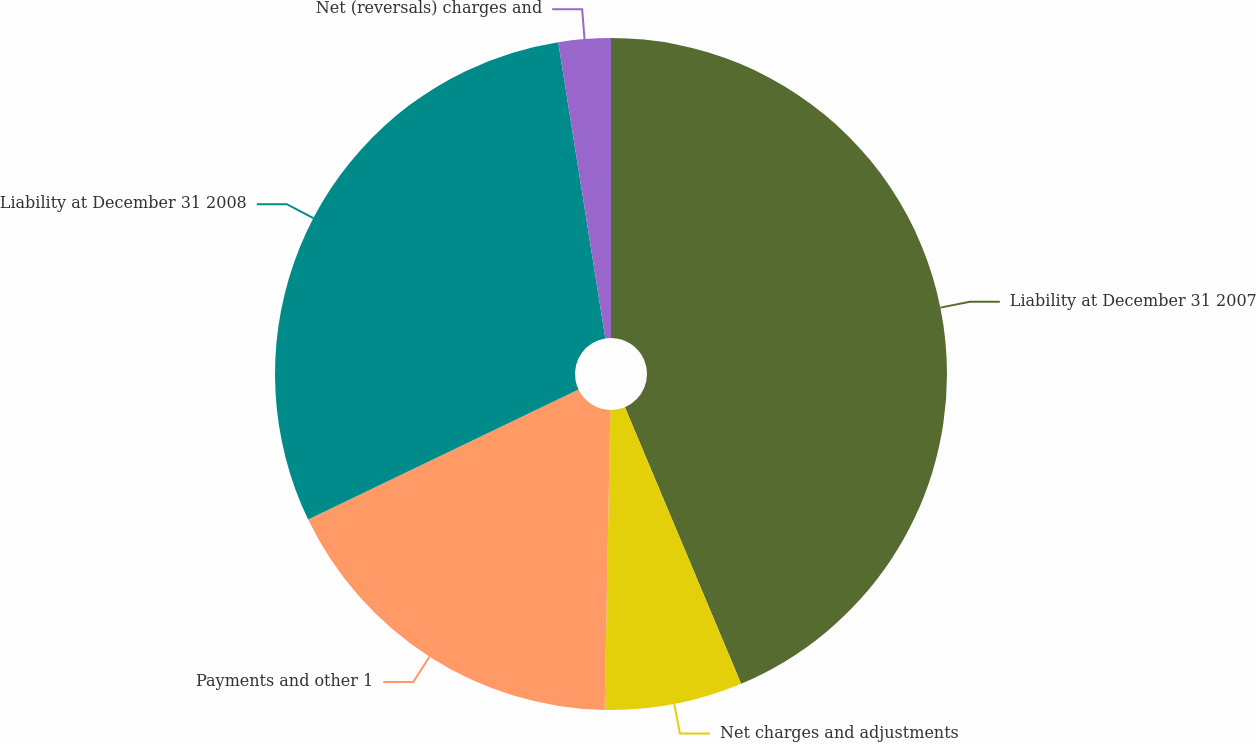Convert chart. <chart><loc_0><loc_0><loc_500><loc_500><pie_chart><fcel>Liability at December 31 2007<fcel>Net charges and adjustments<fcel>Payments and other 1<fcel>Liability at December 31 2008<fcel>Net (reversals) charges and<nl><fcel>43.67%<fcel>6.63%<fcel>17.57%<fcel>29.62%<fcel>2.51%<nl></chart> 